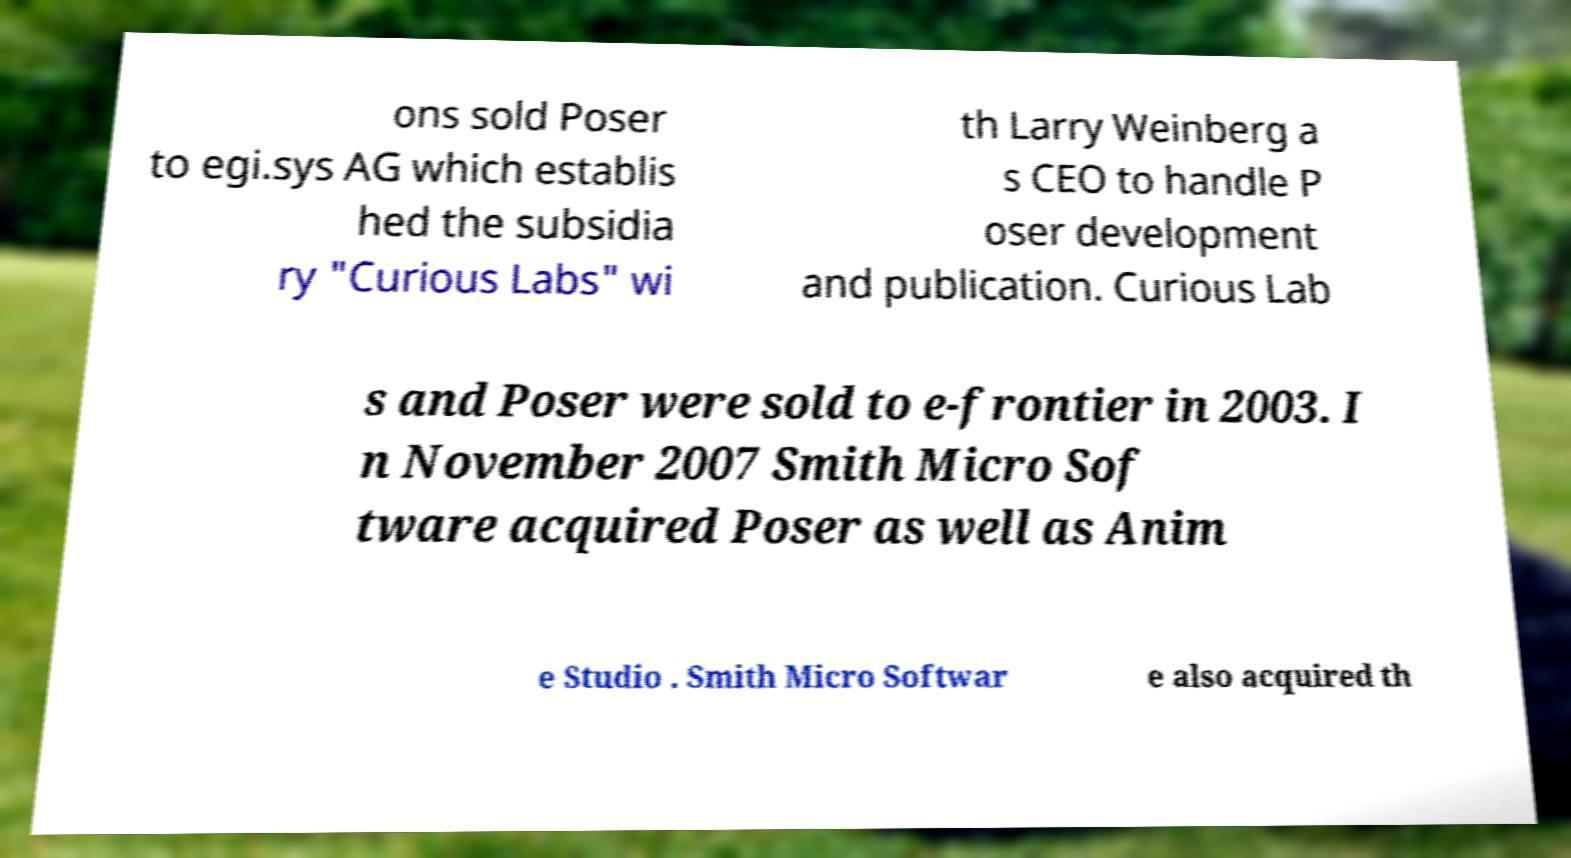Could you assist in decoding the text presented in this image and type it out clearly? ons sold Poser to egi.sys AG which establis hed the subsidia ry "Curious Labs" wi th Larry Weinberg a s CEO to handle P oser development and publication. Curious Lab s and Poser were sold to e-frontier in 2003. I n November 2007 Smith Micro Sof tware acquired Poser as well as Anim e Studio . Smith Micro Softwar e also acquired th 